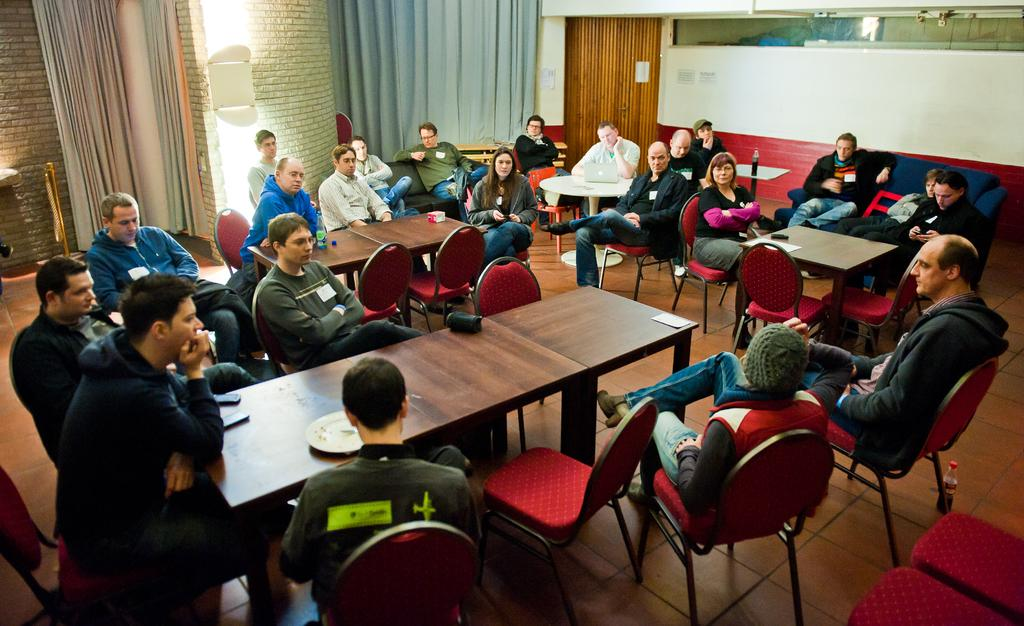How many people are in the image? There is a group of people in the image. Where are the people located in the image? The people are sitting in a room. What are the people doing in the image? The people are engaged in a discussion. What type of ornament is hanging from the wrist of one of the people in the image? There is no ornament hanging from anyone's wrist in the image. 